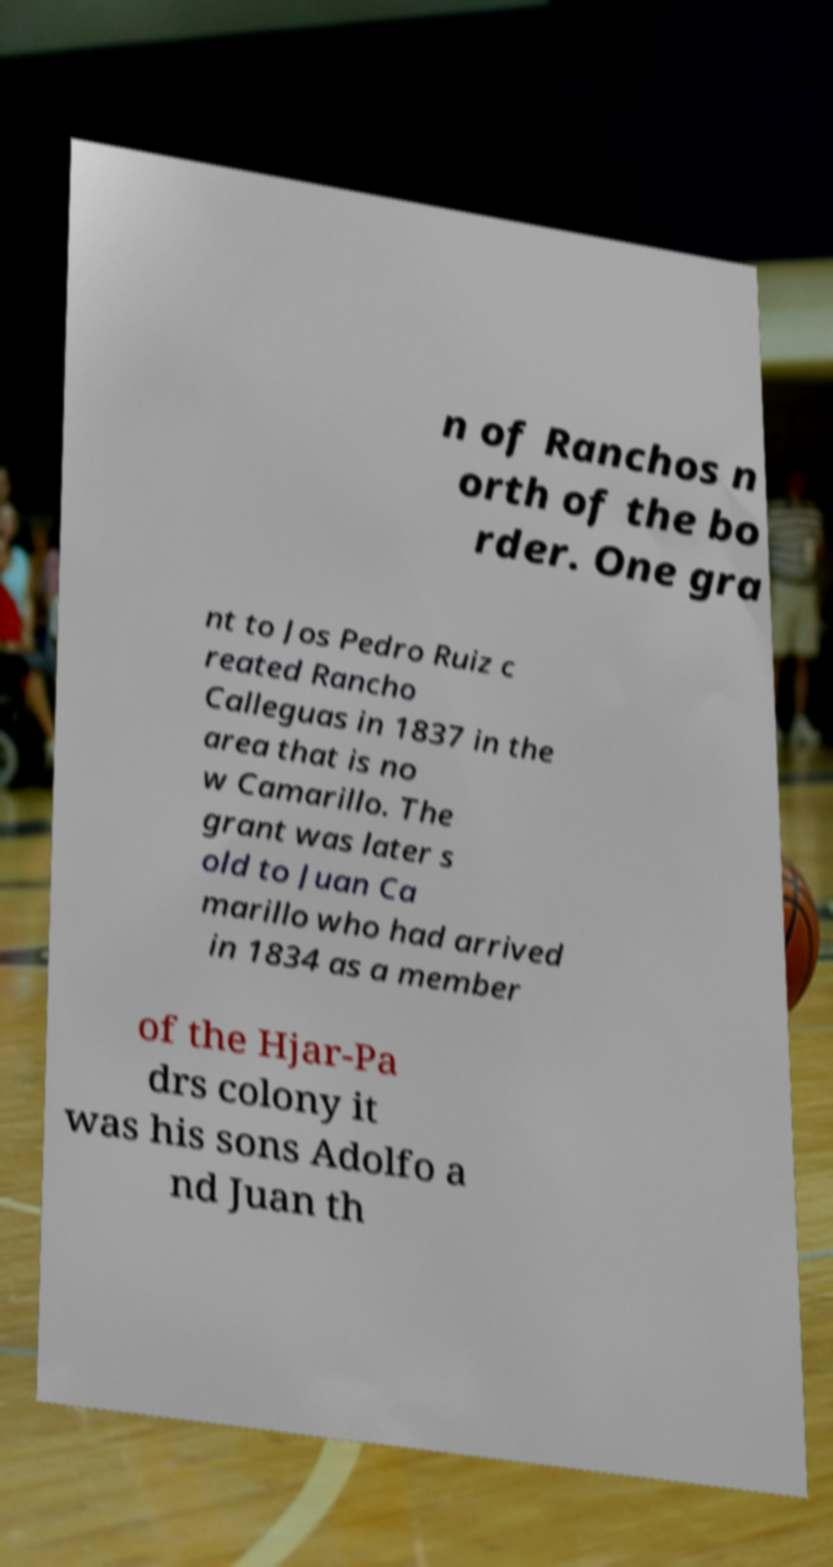There's text embedded in this image that I need extracted. Can you transcribe it verbatim? n of Ranchos n orth of the bo rder. One gra nt to Jos Pedro Ruiz c reated Rancho Calleguas in 1837 in the area that is no w Camarillo. The grant was later s old to Juan Ca marillo who had arrived in 1834 as a member of the Hjar-Pa drs colony it was his sons Adolfo a nd Juan th 